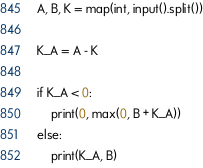Convert code to text. <code><loc_0><loc_0><loc_500><loc_500><_Python_>A, B, K = map(int, input().split())

K_A = A - K

if K_A < 0:
    print(0, max(0, B + K_A))
else:
    print(K_A, B)</code> 